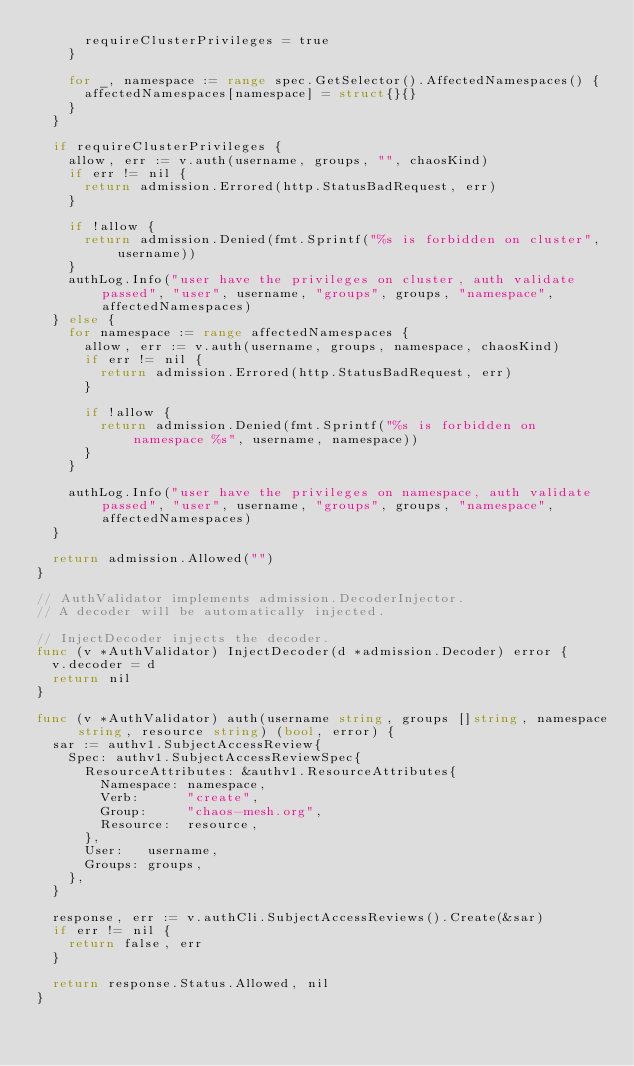Convert code to text. <code><loc_0><loc_0><loc_500><loc_500><_Go_>			requireClusterPrivileges = true
		}

		for _, namespace := range spec.GetSelector().AffectedNamespaces() {
			affectedNamespaces[namespace] = struct{}{}
		}
	}

	if requireClusterPrivileges {
		allow, err := v.auth(username, groups, "", chaosKind)
		if err != nil {
			return admission.Errored(http.StatusBadRequest, err)
		}

		if !allow {
			return admission.Denied(fmt.Sprintf("%s is forbidden on cluster", username))
		}
		authLog.Info("user have the privileges on cluster, auth validate passed", "user", username, "groups", groups, "namespace", affectedNamespaces)
	} else {
		for namespace := range affectedNamespaces {
			allow, err := v.auth(username, groups, namespace, chaosKind)
			if err != nil {
				return admission.Errored(http.StatusBadRequest, err)
			}

			if !allow {
				return admission.Denied(fmt.Sprintf("%s is forbidden on namespace %s", username, namespace))
			}
		}

		authLog.Info("user have the privileges on namespace, auth validate passed", "user", username, "groups", groups, "namespace", affectedNamespaces)
	}

	return admission.Allowed("")
}

// AuthValidator implements admission.DecoderInjector.
// A decoder will be automatically injected.

// InjectDecoder injects the decoder.
func (v *AuthValidator) InjectDecoder(d *admission.Decoder) error {
	v.decoder = d
	return nil
}

func (v *AuthValidator) auth(username string, groups []string, namespace string, resource string) (bool, error) {
	sar := authv1.SubjectAccessReview{
		Spec: authv1.SubjectAccessReviewSpec{
			ResourceAttributes: &authv1.ResourceAttributes{
				Namespace: namespace,
				Verb:      "create",
				Group:     "chaos-mesh.org",
				Resource:  resource,
			},
			User:   username,
			Groups: groups,
		},
	}

	response, err := v.authCli.SubjectAccessReviews().Create(&sar)
	if err != nil {
		return false, err
	}

	return response.Status.Allowed, nil
}
</code> 